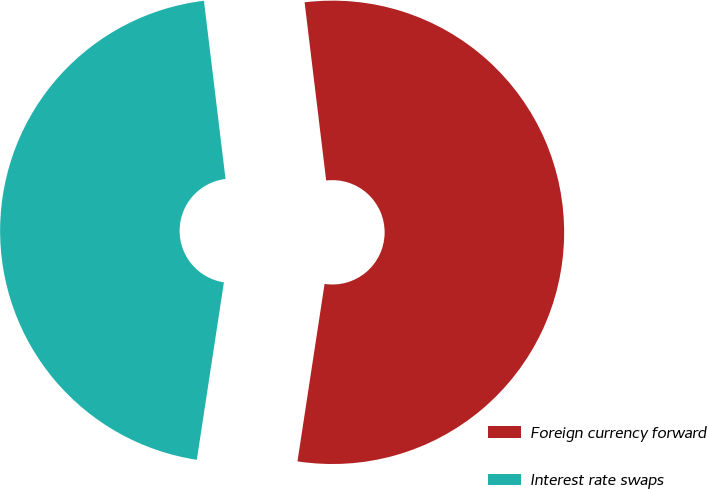Convert chart. <chart><loc_0><loc_0><loc_500><loc_500><pie_chart><fcel>Foreign currency forward<fcel>Interest rate swaps<nl><fcel>54.33%<fcel>45.67%<nl></chart> 